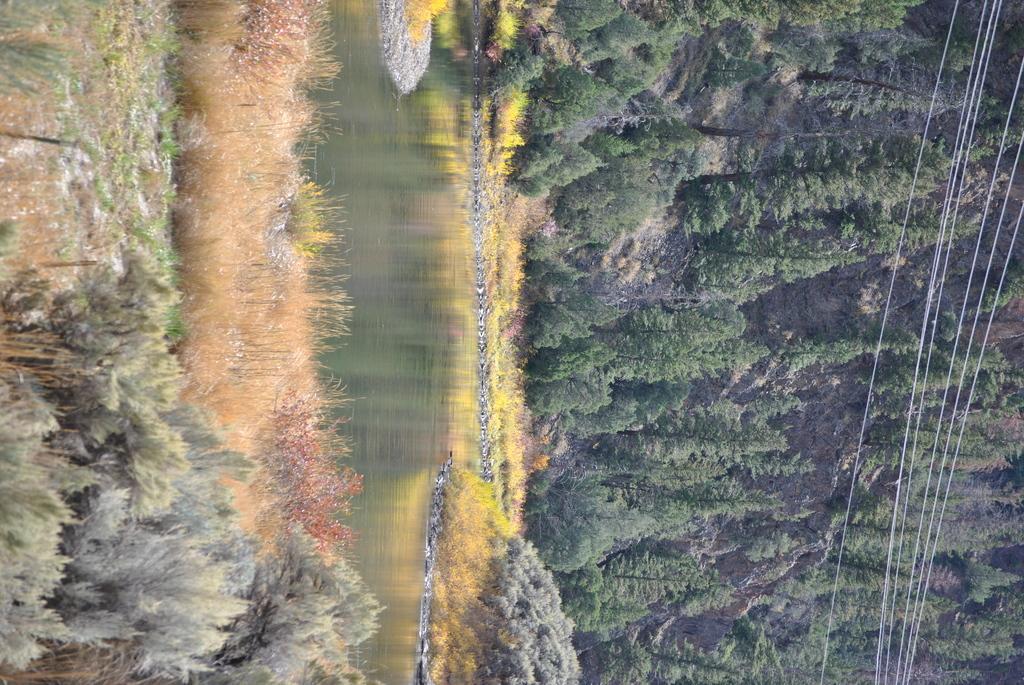How would you summarize this image in a sentence or two? In this image on the right, there are trees and cables. In the middle there is water. At the bottom there are plants, grass and land. 